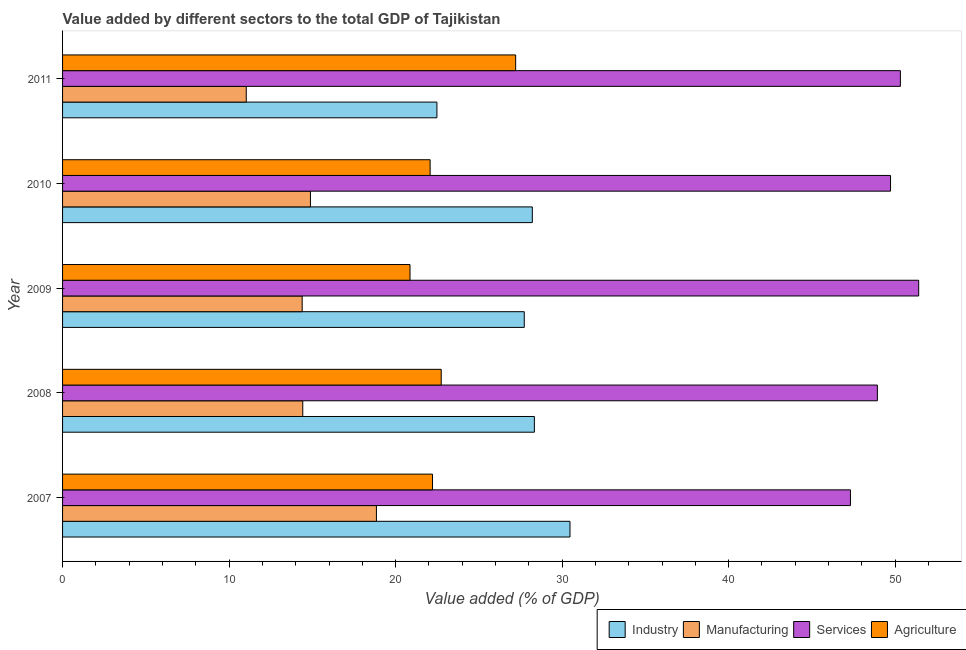How many different coloured bars are there?
Keep it short and to the point. 4. How many groups of bars are there?
Keep it short and to the point. 5. Are the number of bars on each tick of the Y-axis equal?
Give a very brief answer. Yes. What is the value added by manufacturing sector in 2011?
Make the answer very short. 11.03. Across all years, what is the maximum value added by agricultural sector?
Offer a very short reply. 27.21. Across all years, what is the minimum value added by manufacturing sector?
Offer a terse response. 11.03. In which year was the value added by services sector maximum?
Offer a very short reply. 2009. In which year was the value added by industrial sector minimum?
Give a very brief answer. 2011. What is the total value added by manufacturing sector in the graph?
Provide a succinct answer. 73.58. What is the difference between the value added by agricultural sector in 2008 and that in 2011?
Provide a short and direct response. -4.47. What is the difference between the value added by agricultural sector in 2009 and the value added by services sector in 2007?
Ensure brevity in your answer.  -26.45. What is the average value added by agricultural sector per year?
Your response must be concise. 23.02. In the year 2011, what is the difference between the value added by manufacturing sector and value added by services sector?
Give a very brief answer. -39.28. In how many years, is the value added by manufacturing sector greater than 34 %?
Provide a short and direct response. 0. What is the ratio of the value added by agricultural sector in 2010 to that in 2011?
Offer a very short reply. 0.81. Is the difference between the value added by industrial sector in 2009 and 2011 greater than the difference between the value added by services sector in 2009 and 2011?
Your response must be concise. Yes. What is the difference between the highest and the second highest value added by manufacturing sector?
Your response must be concise. 3.96. What is the difference between the highest and the lowest value added by industrial sector?
Offer a terse response. 7.99. Is the sum of the value added by manufacturing sector in 2007 and 2011 greater than the maximum value added by services sector across all years?
Give a very brief answer. No. What does the 2nd bar from the top in 2007 represents?
Make the answer very short. Services. What does the 1st bar from the bottom in 2007 represents?
Offer a very short reply. Industry. Is it the case that in every year, the sum of the value added by industrial sector and value added by manufacturing sector is greater than the value added by services sector?
Ensure brevity in your answer.  No. How many years are there in the graph?
Provide a short and direct response. 5. Are the values on the major ticks of X-axis written in scientific E-notation?
Your answer should be compact. No. Does the graph contain any zero values?
Provide a succinct answer. No. Where does the legend appear in the graph?
Make the answer very short. Bottom right. How many legend labels are there?
Your answer should be compact. 4. What is the title of the graph?
Your answer should be compact. Value added by different sectors to the total GDP of Tajikistan. Does "Social equity" appear as one of the legend labels in the graph?
Offer a very short reply. No. What is the label or title of the X-axis?
Provide a succinct answer. Value added (% of GDP). What is the label or title of the Y-axis?
Offer a terse response. Year. What is the Value added (% of GDP) in Industry in 2007?
Your response must be concise. 30.47. What is the Value added (% of GDP) in Manufacturing in 2007?
Provide a short and direct response. 18.85. What is the Value added (% of GDP) in Services in 2007?
Offer a terse response. 47.31. What is the Value added (% of GDP) in Agriculture in 2007?
Make the answer very short. 22.22. What is the Value added (% of GDP) in Industry in 2008?
Your response must be concise. 28.33. What is the Value added (% of GDP) of Manufacturing in 2008?
Offer a terse response. 14.42. What is the Value added (% of GDP) in Services in 2008?
Offer a very short reply. 48.93. What is the Value added (% of GDP) of Agriculture in 2008?
Keep it short and to the point. 22.74. What is the Value added (% of GDP) of Industry in 2009?
Ensure brevity in your answer.  27.72. What is the Value added (% of GDP) of Manufacturing in 2009?
Your answer should be very brief. 14.39. What is the Value added (% of GDP) in Services in 2009?
Offer a terse response. 51.41. What is the Value added (% of GDP) of Agriculture in 2009?
Provide a short and direct response. 20.86. What is the Value added (% of GDP) of Industry in 2010?
Provide a short and direct response. 28.21. What is the Value added (% of GDP) of Manufacturing in 2010?
Provide a short and direct response. 14.89. What is the Value added (% of GDP) in Services in 2010?
Your response must be concise. 49.72. What is the Value added (% of GDP) of Agriculture in 2010?
Keep it short and to the point. 22.07. What is the Value added (% of GDP) of Industry in 2011?
Provide a short and direct response. 22.48. What is the Value added (% of GDP) of Manufacturing in 2011?
Your response must be concise. 11.03. What is the Value added (% of GDP) in Services in 2011?
Give a very brief answer. 50.31. What is the Value added (% of GDP) of Agriculture in 2011?
Provide a short and direct response. 27.21. Across all years, what is the maximum Value added (% of GDP) of Industry?
Provide a succinct answer. 30.47. Across all years, what is the maximum Value added (% of GDP) in Manufacturing?
Give a very brief answer. 18.85. Across all years, what is the maximum Value added (% of GDP) of Services?
Keep it short and to the point. 51.41. Across all years, what is the maximum Value added (% of GDP) in Agriculture?
Give a very brief answer. 27.21. Across all years, what is the minimum Value added (% of GDP) of Industry?
Give a very brief answer. 22.48. Across all years, what is the minimum Value added (% of GDP) in Manufacturing?
Offer a very short reply. 11.03. Across all years, what is the minimum Value added (% of GDP) in Services?
Provide a succinct answer. 47.31. Across all years, what is the minimum Value added (% of GDP) of Agriculture?
Ensure brevity in your answer.  20.86. What is the total Value added (% of GDP) in Industry in the graph?
Provide a short and direct response. 137.22. What is the total Value added (% of GDP) in Manufacturing in the graph?
Provide a short and direct response. 73.58. What is the total Value added (% of GDP) in Services in the graph?
Keep it short and to the point. 247.68. What is the total Value added (% of GDP) in Agriculture in the graph?
Provide a short and direct response. 115.1. What is the difference between the Value added (% of GDP) of Industry in 2007 and that in 2008?
Offer a very short reply. 2.14. What is the difference between the Value added (% of GDP) of Manufacturing in 2007 and that in 2008?
Your response must be concise. 4.42. What is the difference between the Value added (% of GDP) of Services in 2007 and that in 2008?
Make the answer very short. -1.62. What is the difference between the Value added (% of GDP) in Agriculture in 2007 and that in 2008?
Provide a succinct answer. -0.52. What is the difference between the Value added (% of GDP) of Industry in 2007 and that in 2009?
Provide a succinct answer. 2.75. What is the difference between the Value added (% of GDP) of Manufacturing in 2007 and that in 2009?
Provide a short and direct response. 4.46. What is the difference between the Value added (% of GDP) of Services in 2007 and that in 2009?
Ensure brevity in your answer.  -4.1. What is the difference between the Value added (% of GDP) in Agriculture in 2007 and that in 2009?
Your answer should be compact. 1.35. What is the difference between the Value added (% of GDP) of Industry in 2007 and that in 2010?
Your response must be concise. 2.26. What is the difference between the Value added (% of GDP) in Manufacturing in 2007 and that in 2010?
Provide a succinct answer. 3.96. What is the difference between the Value added (% of GDP) in Services in 2007 and that in 2010?
Give a very brief answer. -2.41. What is the difference between the Value added (% of GDP) in Agriculture in 2007 and that in 2010?
Your answer should be compact. 0.14. What is the difference between the Value added (% of GDP) in Industry in 2007 and that in 2011?
Make the answer very short. 7.99. What is the difference between the Value added (% of GDP) of Manufacturing in 2007 and that in 2011?
Provide a succinct answer. 7.82. What is the difference between the Value added (% of GDP) of Services in 2007 and that in 2011?
Give a very brief answer. -3. What is the difference between the Value added (% of GDP) in Agriculture in 2007 and that in 2011?
Make the answer very short. -4.99. What is the difference between the Value added (% of GDP) in Industry in 2008 and that in 2009?
Provide a succinct answer. 0.61. What is the difference between the Value added (% of GDP) of Manufacturing in 2008 and that in 2009?
Offer a terse response. 0.04. What is the difference between the Value added (% of GDP) of Services in 2008 and that in 2009?
Your answer should be very brief. -2.48. What is the difference between the Value added (% of GDP) in Agriculture in 2008 and that in 2009?
Your answer should be very brief. 1.87. What is the difference between the Value added (% of GDP) of Industry in 2008 and that in 2010?
Your answer should be compact. 0.12. What is the difference between the Value added (% of GDP) of Manufacturing in 2008 and that in 2010?
Provide a succinct answer. -0.46. What is the difference between the Value added (% of GDP) of Services in 2008 and that in 2010?
Offer a very short reply. -0.79. What is the difference between the Value added (% of GDP) of Agriculture in 2008 and that in 2010?
Keep it short and to the point. 0.67. What is the difference between the Value added (% of GDP) in Industry in 2008 and that in 2011?
Provide a succinct answer. 5.85. What is the difference between the Value added (% of GDP) of Manufacturing in 2008 and that in 2011?
Provide a succinct answer. 3.39. What is the difference between the Value added (% of GDP) of Services in 2008 and that in 2011?
Your answer should be very brief. -1.38. What is the difference between the Value added (% of GDP) in Agriculture in 2008 and that in 2011?
Give a very brief answer. -4.47. What is the difference between the Value added (% of GDP) in Industry in 2009 and that in 2010?
Provide a short and direct response. -0.48. What is the difference between the Value added (% of GDP) of Manufacturing in 2009 and that in 2010?
Offer a terse response. -0.5. What is the difference between the Value added (% of GDP) of Services in 2009 and that in 2010?
Offer a very short reply. 1.69. What is the difference between the Value added (% of GDP) of Agriculture in 2009 and that in 2010?
Your answer should be compact. -1.21. What is the difference between the Value added (% of GDP) in Industry in 2009 and that in 2011?
Your answer should be very brief. 5.25. What is the difference between the Value added (% of GDP) in Manufacturing in 2009 and that in 2011?
Offer a very short reply. 3.36. What is the difference between the Value added (% of GDP) of Services in 2009 and that in 2011?
Offer a very short reply. 1.1. What is the difference between the Value added (% of GDP) of Agriculture in 2009 and that in 2011?
Offer a very short reply. -6.34. What is the difference between the Value added (% of GDP) of Industry in 2010 and that in 2011?
Offer a very short reply. 5.73. What is the difference between the Value added (% of GDP) of Manufacturing in 2010 and that in 2011?
Keep it short and to the point. 3.85. What is the difference between the Value added (% of GDP) in Services in 2010 and that in 2011?
Provide a succinct answer. -0.59. What is the difference between the Value added (% of GDP) of Agriculture in 2010 and that in 2011?
Your response must be concise. -5.14. What is the difference between the Value added (% of GDP) of Industry in 2007 and the Value added (% of GDP) of Manufacturing in 2008?
Keep it short and to the point. 16.05. What is the difference between the Value added (% of GDP) in Industry in 2007 and the Value added (% of GDP) in Services in 2008?
Your answer should be very brief. -18.46. What is the difference between the Value added (% of GDP) of Industry in 2007 and the Value added (% of GDP) of Agriculture in 2008?
Your response must be concise. 7.73. What is the difference between the Value added (% of GDP) in Manufacturing in 2007 and the Value added (% of GDP) in Services in 2008?
Keep it short and to the point. -30.08. What is the difference between the Value added (% of GDP) in Manufacturing in 2007 and the Value added (% of GDP) in Agriculture in 2008?
Provide a succinct answer. -3.89. What is the difference between the Value added (% of GDP) in Services in 2007 and the Value added (% of GDP) in Agriculture in 2008?
Offer a terse response. 24.57. What is the difference between the Value added (% of GDP) in Industry in 2007 and the Value added (% of GDP) in Manufacturing in 2009?
Offer a very short reply. 16.08. What is the difference between the Value added (% of GDP) of Industry in 2007 and the Value added (% of GDP) of Services in 2009?
Give a very brief answer. -20.94. What is the difference between the Value added (% of GDP) of Industry in 2007 and the Value added (% of GDP) of Agriculture in 2009?
Provide a succinct answer. 9.61. What is the difference between the Value added (% of GDP) in Manufacturing in 2007 and the Value added (% of GDP) in Services in 2009?
Your response must be concise. -32.56. What is the difference between the Value added (% of GDP) of Manufacturing in 2007 and the Value added (% of GDP) of Agriculture in 2009?
Make the answer very short. -2.02. What is the difference between the Value added (% of GDP) in Services in 2007 and the Value added (% of GDP) in Agriculture in 2009?
Make the answer very short. 26.45. What is the difference between the Value added (% of GDP) of Industry in 2007 and the Value added (% of GDP) of Manufacturing in 2010?
Provide a succinct answer. 15.59. What is the difference between the Value added (% of GDP) of Industry in 2007 and the Value added (% of GDP) of Services in 2010?
Provide a short and direct response. -19.25. What is the difference between the Value added (% of GDP) in Industry in 2007 and the Value added (% of GDP) in Agriculture in 2010?
Offer a very short reply. 8.4. What is the difference between the Value added (% of GDP) in Manufacturing in 2007 and the Value added (% of GDP) in Services in 2010?
Your response must be concise. -30.87. What is the difference between the Value added (% of GDP) of Manufacturing in 2007 and the Value added (% of GDP) of Agriculture in 2010?
Your answer should be very brief. -3.22. What is the difference between the Value added (% of GDP) in Services in 2007 and the Value added (% of GDP) in Agriculture in 2010?
Provide a succinct answer. 25.24. What is the difference between the Value added (% of GDP) in Industry in 2007 and the Value added (% of GDP) in Manufacturing in 2011?
Offer a terse response. 19.44. What is the difference between the Value added (% of GDP) in Industry in 2007 and the Value added (% of GDP) in Services in 2011?
Your answer should be compact. -19.84. What is the difference between the Value added (% of GDP) in Industry in 2007 and the Value added (% of GDP) in Agriculture in 2011?
Offer a very short reply. 3.26. What is the difference between the Value added (% of GDP) in Manufacturing in 2007 and the Value added (% of GDP) in Services in 2011?
Provide a short and direct response. -31.46. What is the difference between the Value added (% of GDP) in Manufacturing in 2007 and the Value added (% of GDP) in Agriculture in 2011?
Offer a very short reply. -8.36. What is the difference between the Value added (% of GDP) of Services in 2007 and the Value added (% of GDP) of Agriculture in 2011?
Your response must be concise. 20.11. What is the difference between the Value added (% of GDP) in Industry in 2008 and the Value added (% of GDP) in Manufacturing in 2009?
Offer a terse response. 13.94. What is the difference between the Value added (% of GDP) of Industry in 2008 and the Value added (% of GDP) of Services in 2009?
Keep it short and to the point. -23.08. What is the difference between the Value added (% of GDP) in Industry in 2008 and the Value added (% of GDP) in Agriculture in 2009?
Make the answer very short. 7.47. What is the difference between the Value added (% of GDP) in Manufacturing in 2008 and the Value added (% of GDP) in Services in 2009?
Your response must be concise. -36.99. What is the difference between the Value added (% of GDP) of Manufacturing in 2008 and the Value added (% of GDP) of Agriculture in 2009?
Make the answer very short. -6.44. What is the difference between the Value added (% of GDP) of Services in 2008 and the Value added (% of GDP) of Agriculture in 2009?
Keep it short and to the point. 28.06. What is the difference between the Value added (% of GDP) in Industry in 2008 and the Value added (% of GDP) in Manufacturing in 2010?
Offer a terse response. 13.45. What is the difference between the Value added (% of GDP) in Industry in 2008 and the Value added (% of GDP) in Services in 2010?
Your response must be concise. -21.39. What is the difference between the Value added (% of GDP) of Industry in 2008 and the Value added (% of GDP) of Agriculture in 2010?
Your response must be concise. 6.26. What is the difference between the Value added (% of GDP) in Manufacturing in 2008 and the Value added (% of GDP) in Services in 2010?
Give a very brief answer. -35.3. What is the difference between the Value added (% of GDP) of Manufacturing in 2008 and the Value added (% of GDP) of Agriculture in 2010?
Your answer should be compact. -7.65. What is the difference between the Value added (% of GDP) of Services in 2008 and the Value added (% of GDP) of Agriculture in 2010?
Offer a terse response. 26.86. What is the difference between the Value added (% of GDP) of Industry in 2008 and the Value added (% of GDP) of Manufacturing in 2011?
Keep it short and to the point. 17.3. What is the difference between the Value added (% of GDP) of Industry in 2008 and the Value added (% of GDP) of Services in 2011?
Give a very brief answer. -21.98. What is the difference between the Value added (% of GDP) of Industry in 2008 and the Value added (% of GDP) of Agriculture in 2011?
Ensure brevity in your answer.  1.12. What is the difference between the Value added (% of GDP) in Manufacturing in 2008 and the Value added (% of GDP) in Services in 2011?
Keep it short and to the point. -35.89. What is the difference between the Value added (% of GDP) in Manufacturing in 2008 and the Value added (% of GDP) in Agriculture in 2011?
Make the answer very short. -12.78. What is the difference between the Value added (% of GDP) in Services in 2008 and the Value added (% of GDP) in Agriculture in 2011?
Provide a succinct answer. 21.72. What is the difference between the Value added (% of GDP) in Industry in 2009 and the Value added (% of GDP) in Manufacturing in 2010?
Ensure brevity in your answer.  12.84. What is the difference between the Value added (% of GDP) of Industry in 2009 and the Value added (% of GDP) of Services in 2010?
Your response must be concise. -22. What is the difference between the Value added (% of GDP) of Industry in 2009 and the Value added (% of GDP) of Agriculture in 2010?
Give a very brief answer. 5.65. What is the difference between the Value added (% of GDP) of Manufacturing in 2009 and the Value added (% of GDP) of Services in 2010?
Your answer should be compact. -35.33. What is the difference between the Value added (% of GDP) of Manufacturing in 2009 and the Value added (% of GDP) of Agriculture in 2010?
Ensure brevity in your answer.  -7.68. What is the difference between the Value added (% of GDP) in Services in 2009 and the Value added (% of GDP) in Agriculture in 2010?
Your response must be concise. 29.34. What is the difference between the Value added (% of GDP) of Industry in 2009 and the Value added (% of GDP) of Manufacturing in 2011?
Offer a very short reply. 16.69. What is the difference between the Value added (% of GDP) in Industry in 2009 and the Value added (% of GDP) in Services in 2011?
Make the answer very short. -22.59. What is the difference between the Value added (% of GDP) in Industry in 2009 and the Value added (% of GDP) in Agriculture in 2011?
Offer a terse response. 0.52. What is the difference between the Value added (% of GDP) of Manufacturing in 2009 and the Value added (% of GDP) of Services in 2011?
Provide a succinct answer. -35.92. What is the difference between the Value added (% of GDP) in Manufacturing in 2009 and the Value added (% of GDP) in Agriculture in 2011?
Ensure brevity in your answer.  -12.82. What is the difference between the Value added (% of GDP) of Services in 2009 and the Value added (% of GDP) of Agriculture in 2011?
Ensure brevity in your answer.  24.2. What is the difference between the Value added (% of GDP) in Industry in 2010 and the Value added (% of GDP) in Manufacturing in 2011?
Make the answer very short. 17.18. What is the difference between the Value added (% of GDP) in Industry in 2010 and the Value added (% of GDP) in Services in 2011?
Give a very brief answer. -22.1. What is the difference between the Value added (% of GDP) of Manufacturing in 2010 and the Value added (% of GDP) of Services in 2011?
Ensure brevity in your answer.  -35.43. What is the difference between the Value added (% of GDP) in Manufacturing in 2010 and the Value added (% of GDP) in Agriculture in 2011?
Give a very brief answer. -12.32. What is the difference between the Value added (% of GDP) of Services in 2010 and the Value added (% of GDP) of Agriculture in 2011?
Your answer should be very brief. 22.51. What is the average Value added (% of GDP) of Industry per year?
Make the answer very short. 27.44. What is the average Value added (% of GDP) in Manufacturing per year?
Offer a very short reply. 14.72. What is the average Value added (% of GDP) in Services per year?
Your response must be concise. 49.54. What is the average Value added (% of GDP) in Agriculture per year?
Your answer should be compact. 23.02. In the year 2007, what is the difference between the Value added (% of GDP) in Industry and Value added (% of GDP) in Manufacturing?
Offer a very short reply. 11.62. In the year 2007, what is the difference between the Value added (% of GDP) in Industry and Value added (% of GDP) in Services?
Your answer should be very brief. -16.84. In the year 2007, what is the difference between the Value added (% of GDP) of Industry and Value added (% of GDP) of Agriculture?
Offer a very short reply. 8.26. In the year 2007, what is the difference between the Value added (% of GDP) of Manufacturing and Value added (% of GDP) of Services?
Make the answer very short. -28.47. In the year 2007, what is the difference between the Value added (% of GDP) in Manufacturing and Value added (% of GDP) in Agriculture?
Make the answer very short. -3.37. In the year 2007, what is the difference between the Value added (% of GDP) in Services and Value added (% of GDP) in Agriculture?
Provide a succinct answer. 25.1. In the year 2008, what is the difference between the Value added (% of GDP) of Industry and Value added (% of GDP) of Manufacturing?
Make the answer very short. 13.91. In the year 2008, what is the difference between the Value added (% of GDP) of Industry and Value added (% of GDP) of Services?
Keep it short and to the point. -20.6. In the year 2008, what is the difference between the Value added (% of GDP) in Industry and Value added (% of GDP) in Agriculture?
Provide a short and direct response. 5.59. In the year 2008, what is the difference between the Value added (% of GDP) in Manufacturing and Value added (% of GDP) in Services?
Provide a short and direct response. -34.51. In the year 2008, what is the difference between the Value added (% of GDP) in Manufacturing and Value added (% of GDP) in Agriculture?
Make the answer very short. -8.31. In the year 2008, what is the difference between the Value added (% of GDP) in Services and Value added (% of GDP) in Agriculture?
Ensure brevity in your answer.  26.19. In the year 2009, what is the difference between the Value added (% of GDP) in Industry and Value added (% of GDP) in Manufacturing?
Provide a short and direct response. 13.34. In the year 2009, what is the difference between the Value added (% of GDP) of Industry and Value added (% of GDP) of Services?
Keep it short and to the point. -23.69. In the year 2009, what is the difference between the Value added (% of GDP) of Industry and Value added (% of GDP) of Agriculture?
Offer a very short reply. 6.86. In the year 2009, what is the difference between the Value added (% of GDP) of Manufacturing and Value added (% of GDP) of Services?
Provide a short and direct response. -37.02. In the year 2009, what is the difference between the Value added (% of GDP) of Manufacturing and Value added (% of GDP) of Agriculture?
Make the answer very short. -6.48. In the year 2009, what is the difference between the Value added (% of GDP) of Services and Value added (% of GDP) of Agriculture?
Give a very brief answer. 30.55. In the year 2010, what is the difference between the Value added (% of GDP) in Industry and Value added (% of GDP) in Manufacturing?
Offer a very short reply. 13.32. In the year 2010, what is the difference between the Value added (% of GDP) in Industry and Value added (% of GDP) in Services?
Provide a succinct answer. -21.51. In the year 2010, what is the difference between the Value added (% of GDP) of Industry and Value added (% of GDP) of Agriculture?
Provide a succinct answer. 6.14. In the year 2010, what is the difference between the Value added (% of GDP) of Manufacturing and Value added (% of GDP) of Services?
Your response must be concise. -34.83. In the year 2010, what is the difference between the Value added (% of GDP) in Manufacturing and Value added (% of GDP) in Agriculture?
Your answer should be compact. -7.19. In the year 2010, what is the difference between the Value added (% of GDP) of Services and Value added (% of GDP) of Agriculture?
Ensure brevity in your answer.  27.65. In the year 2011, what is the difference between the Value added (% of GDP) in Industry and Value added (% of GDP) in Manufacturing?
Your answer should be very brief. 11.45. In the year 2011, what is the difference between the Value added (% of GDP) in Industry and Value added (% of GDP) in Services?
Provide a succinct answer. -27.83. In the year 2011, what is the difference between the Value added (% of GDP) in Industry and Value added (% of GDP) in Agriculture?
Offer a terse response. -4.73. In the year 2011, what is the difference between the Value added (% of GDP) of Manufacturing and Value added (% of GDP) of Services?
Offer a very short reply. -39.28. In the year 2011, what is the difference between the Value added (% of GDP) in Manufacturing and Value added (% of GDP) in Agriculture?
Make the answer very short. -16.18. In the year 2011, what is the difference between the Value added (% of GDP) in Services and Value added (% of GDP) in Agriculture?
Keep it short and to the point. 23.1. What is the ratio of the Value added (% of GDP) in Industry in 2007 to that in 2008?
Offer a very short reply. 1.08. What is the ratio of the Value added (% of GDP) of Manufacturing in 2007 to that in 2008?
Your response must be concise. 1.31. What is the ratio of the Value added (% of GDP) in Industry in 2007 to that in 2009?
Offer a very short reply. 1.1. What is the ratio of the Value added (% of GDP) in Manufacturing in 2007 to that in 2009?
Keep it short and to the point. 1.31. What is the ratio of the Value added (% of GDP) of Services in 2007 to that in 2009?
Offer a very short reply. 0.92. What is the ratio of the Value added (% of GDP) in Agriculture in 2007 to that in 2009?
Give a very brief answer. 1.06. What is the ratio of the Value added (% of GDP) of Industry in 2007 to that in 2010?
Your answer should be compact. 1.08. What is the ratio of the Value added (% of GDP) of Manufacturing in 2007 to that in 2010?
Your answer should be compact. 1.27. What is the ratio of the Value added (% of GDP) in Services in 2007 to that in 2010?
Offer a very short reply. 0.95. What is the ratio of the Value added (% of GDP) in Agriculture in 2007 to that in 2010?
Ensure brevity in your answer.  1.01. What is the ratio of the Value added (% of GDP) of Industry in 2007 to that in 2011?
Your answer should be compact. 1.36. What is the ratio of the Value added (% of GDP) of Manufacturing in 2007 to that in 2011?
Ensure brevity in your answer.  1.71. What is the ratio of the Value added (% of GDP) of Services in 2007 to that in 2011?
Keep it short and to the point. 0.94. What is the ratio of the Value added (% of GDP) of Agriculture in 2007 to that in 2011?
Provide a short and direct response. 0.82. What is the ratio of the Value added (% of GDP) in Industry in 2008 to that in 2009?
Ensure brevity in your answer.  1.02. What is the ratio of the Value added (% of GDP) of Services in 2008 to that in 2009?
Make the answer very short. 0.95. What is the ratio of the Value added (% of GDP) of Agriculture in 2008 to that in 2009?
Keep it short and to the point. 1.09. What is the ratio of the Value added (% of GDP) in Services in 2008 to that in 2010?
Offer a terse response. 0.98. What is the ratio of the Value added (% of GDP) in Agriculture in 2008 to that in 2010?
Keep it short and to the point. 1.03. What is the ratio of the Value added (% of GDP) of Industry in 2008 to that in 2011?
Make the answer very short. 1.26. What is the ratio of the Value added (% of GDP) in Manufacturing in 2008 to that in 2011?
Give a very brief answer. 1.31. What is the ratio of the Value added (% of GDP) in Services in 2008 to that in 2011?
Your response must be concise. 0.97. What is the ratio of the Value added (% of GDP) in Agriculture in 2008 to that in 2011?
Give a very brief answer. 0.84. What is the ratio of the Value added (% of GDP) of Industry in 2009 to that in 2010?
Give a very brief answer. 0.98. What is the ratio of the Value added (% of GDP) of Manufacturing in 2009 to that in 2010?
Keep it short and to the point. 0.97. What is the ratio of the Value added (% of GDP) of Services in 2009 to that in 2010?
Provide a succinct answer. 1.03. What is the ratio of the Value added (% of GDP) of Agriculture in 2009 to that in 2010?
Provide a succinct answer. 0.95. What is the ratio of the Value added (% of GDP) of Industry in 2009 to that in 2011?
Your answer should be very brief. 1.23. What is the ratio of the Value added (% of GDP) of Manufacturing in 2009 to that in 2011?
Your response must be concise. 1.3. What is the ratio of the Value added (% of GDP) in Services in 2009 to that in 2011?
Make the answer very short. 1.02. What is the ratio of the Value added (% of GDP) of Agriculture in 2009 to that in 2011?
Make the answer very short. 0.77. What is the ratio of the Value added (% of GDP) of Industry in 2010 to that in 2011?
Your answer should be very brief. 1.25. What is the ratio of the Value added (% of GDP) of Manufacturing in 2010 to that in 2011?
Give a very brief answer. 1.35. What is the ratio of the Value added (% of GDP) of Services in 2010 to that in 2011?
Make the answer very short. 0.99. What is the ratio of the Value added (% of GDP) in Agriculture in 2010 to that in 2011?
Offer a terse response. 0.81. What is the difference between the highest and the second highest Value added (% of GDP) in Industry?
Your answer should be compact. 2.14. What is the difference between the highest and the second highest Value added (% of GDP) in Manufacturing?
Make the answer very short. 3.96. What is the difference between the highest and the second highest Value added (% of GDP) of Services?
Ensure brevity in your answer.  1.1. What is the difference between the highest and the second highest Value added (% of GDP) of Agriculture?
Give a very brief answer. 4.47. What is the difference between the highest and the lowest Value added (% of GDP) of Industry?
Offer a terse response. 7.99. What is the difference between the highest and the lowest Value added (% of GDP) in Manufacturing?
Give a very brief answer. 7.82. What is the difference between the highest and the lowest Value added (% of GDP) of Services?
Offer a terse response. 4.1. What is the difference between the highest and the lowest Value added (% of GDP) in Agriculture?
Provide a short and direct response. 6.34. 